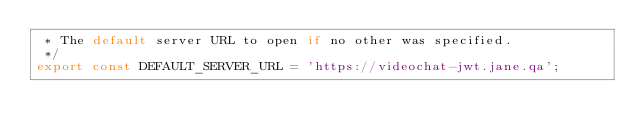<code> <loc_0><loc_0><loc_500><loc_500><_JavaScript_> * The default server URL to open if no other was specified.
 */
export const DEFAULT_SERVER_URL = 'https://videochat-jwt.jane.qa';
</code> 